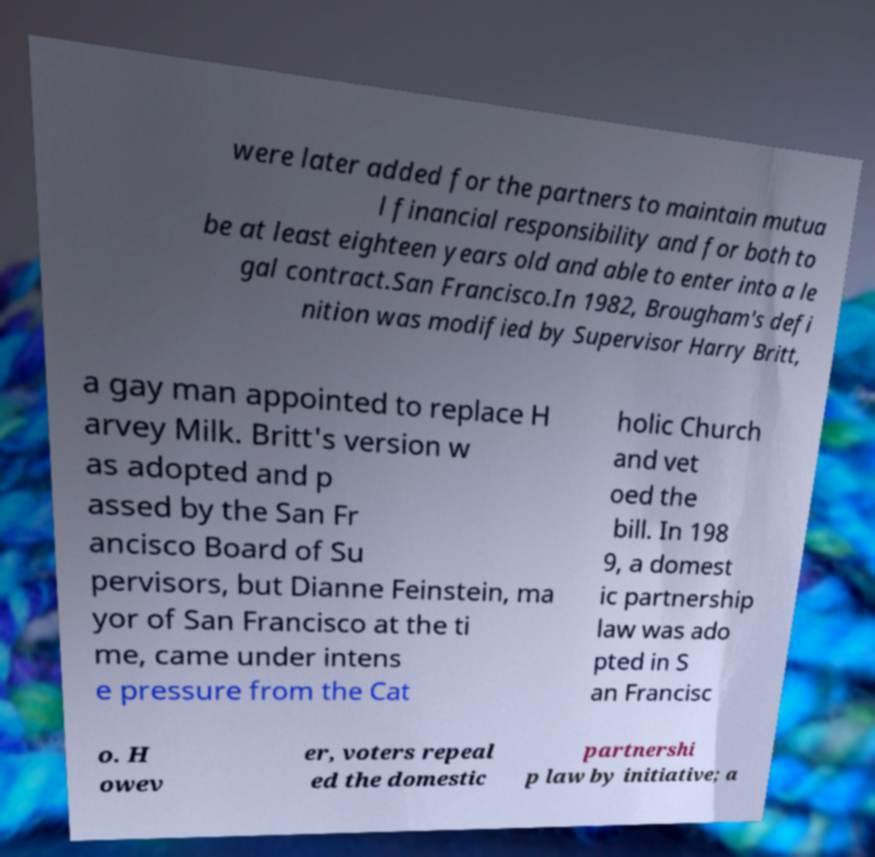Please read and relay the text visible in this image. What does it say? were later added for the partners to maintain mutua l financial responsibility and for both to be at least eighteen years old and able to enter into a le gal contract.San Francisco.In 1982, Brougham's defi nition was modified by Supervisor Harry Britt, a gay man appointed to replace H arvey Milk. Britt's version w as adopted and p assed by the San Fr ancisco Board of Su pervisors, but Dianne Feinstein, ma yor of San Francisco at the ti me, came under intens e pressure from the Cat holic Church and vet oed the bill. In 198 9, a domest ic partnership law was ado pted in S an Francisc o. H owev er, voters repeal ed the domestic partnershi p law by initiative; a 